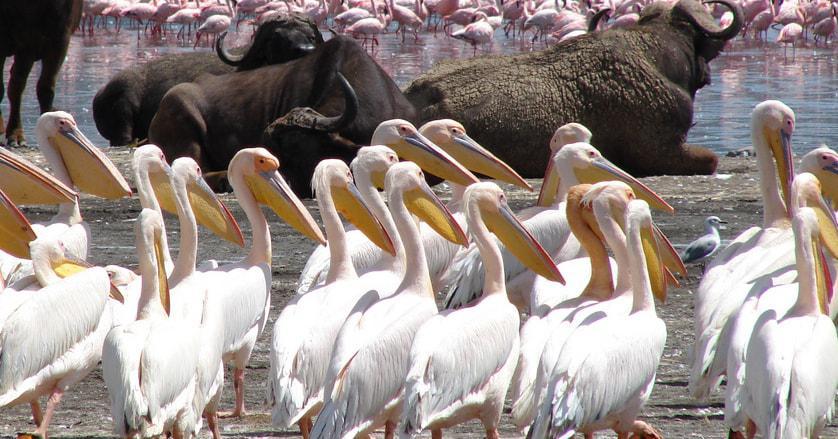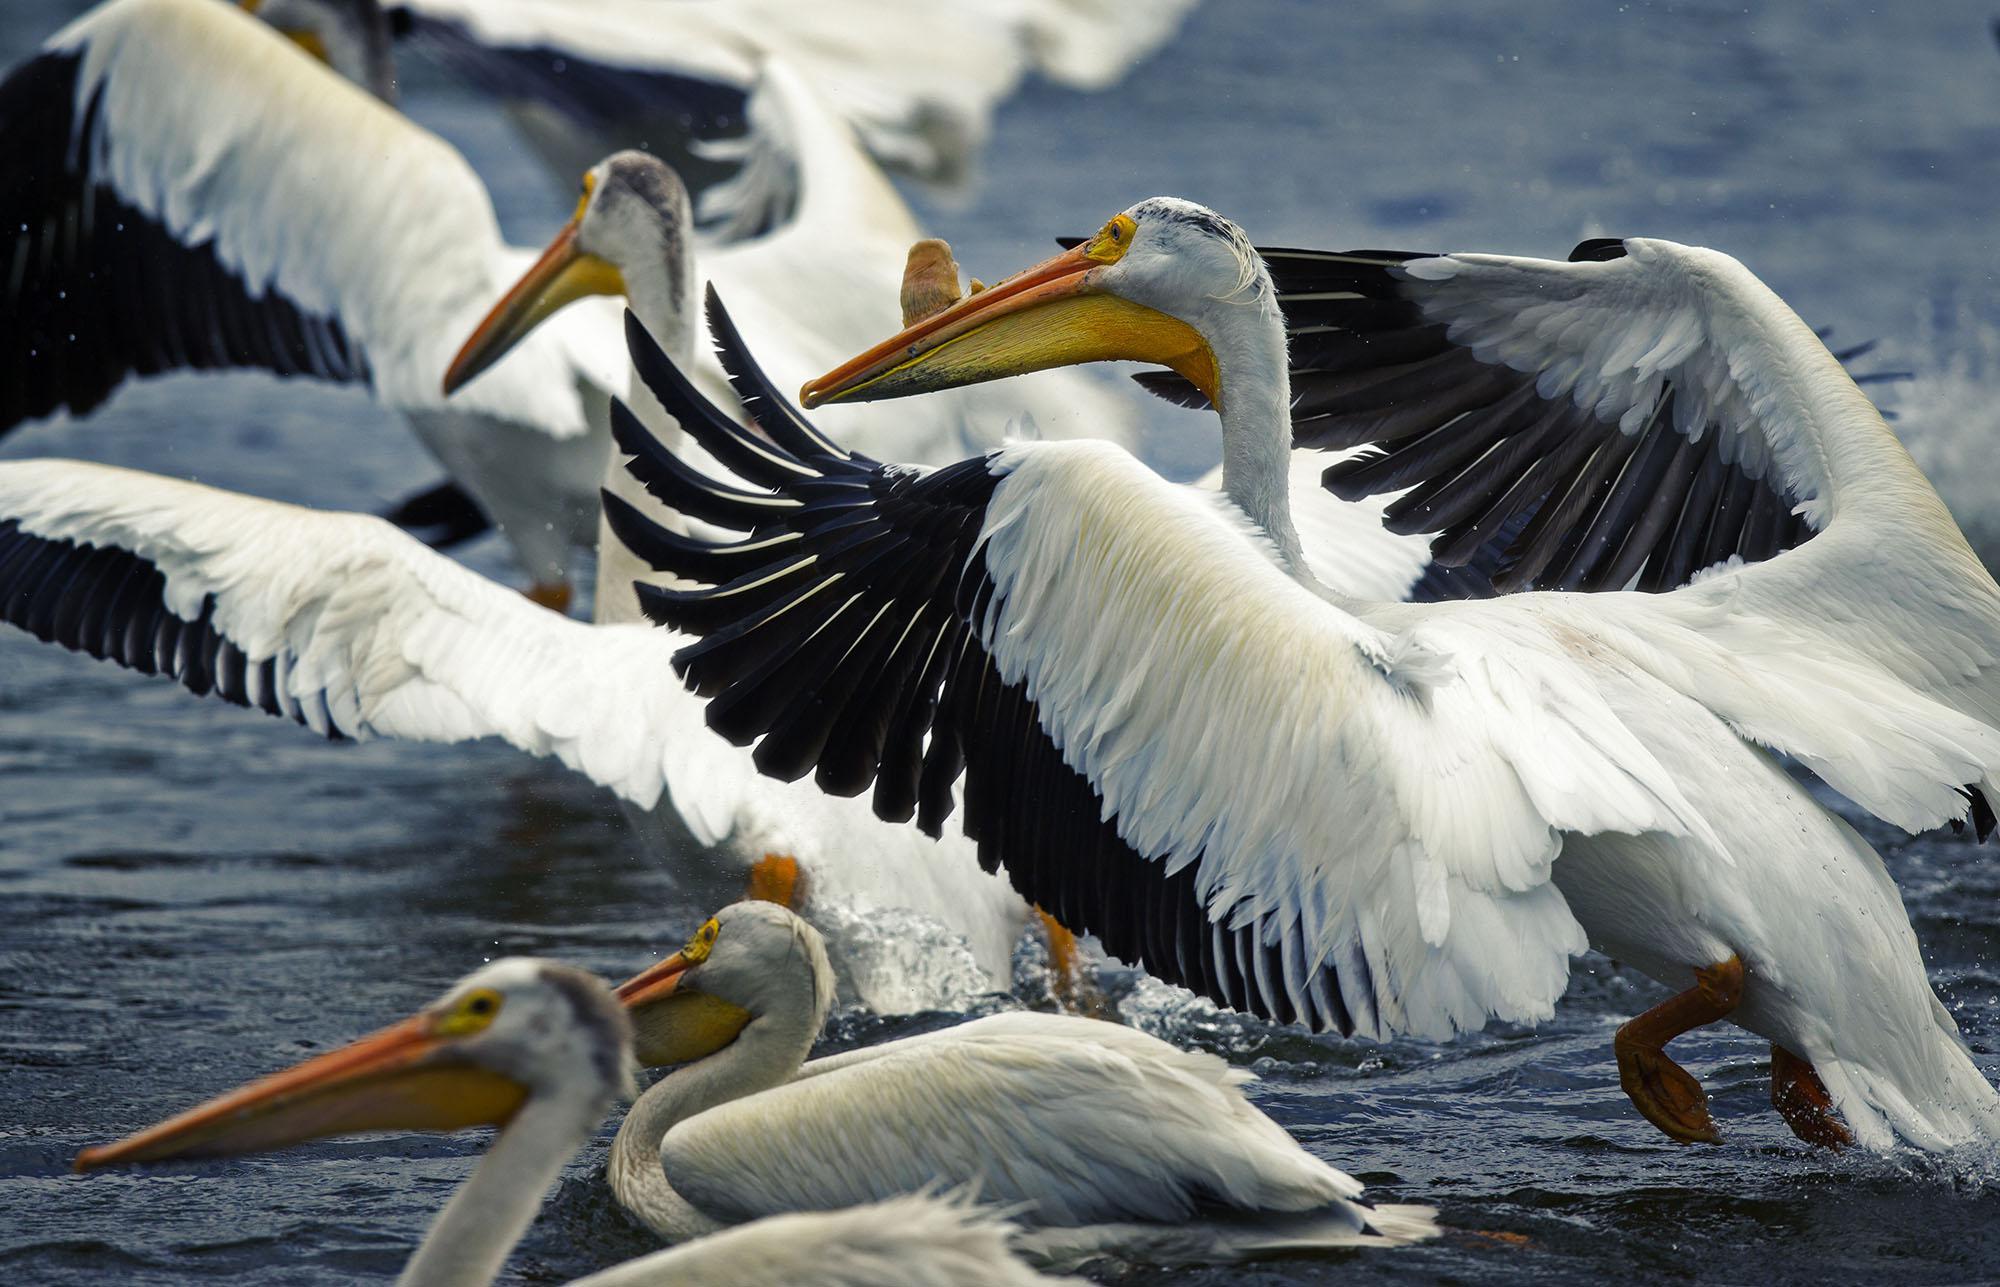The first image is the image on the left, the second image is the image on the right. Evaluate the accuracy of this statement regarding the images: "There are exactly three pelicans in one of the images". Is it true? Answer yes or no. No. The first image is the image on the left, the second image is the image on the right. Evaluate the accuracy of this statement regarding the images: "There are 3 storks on the left image". Is it true? Answer yes or no. No. 